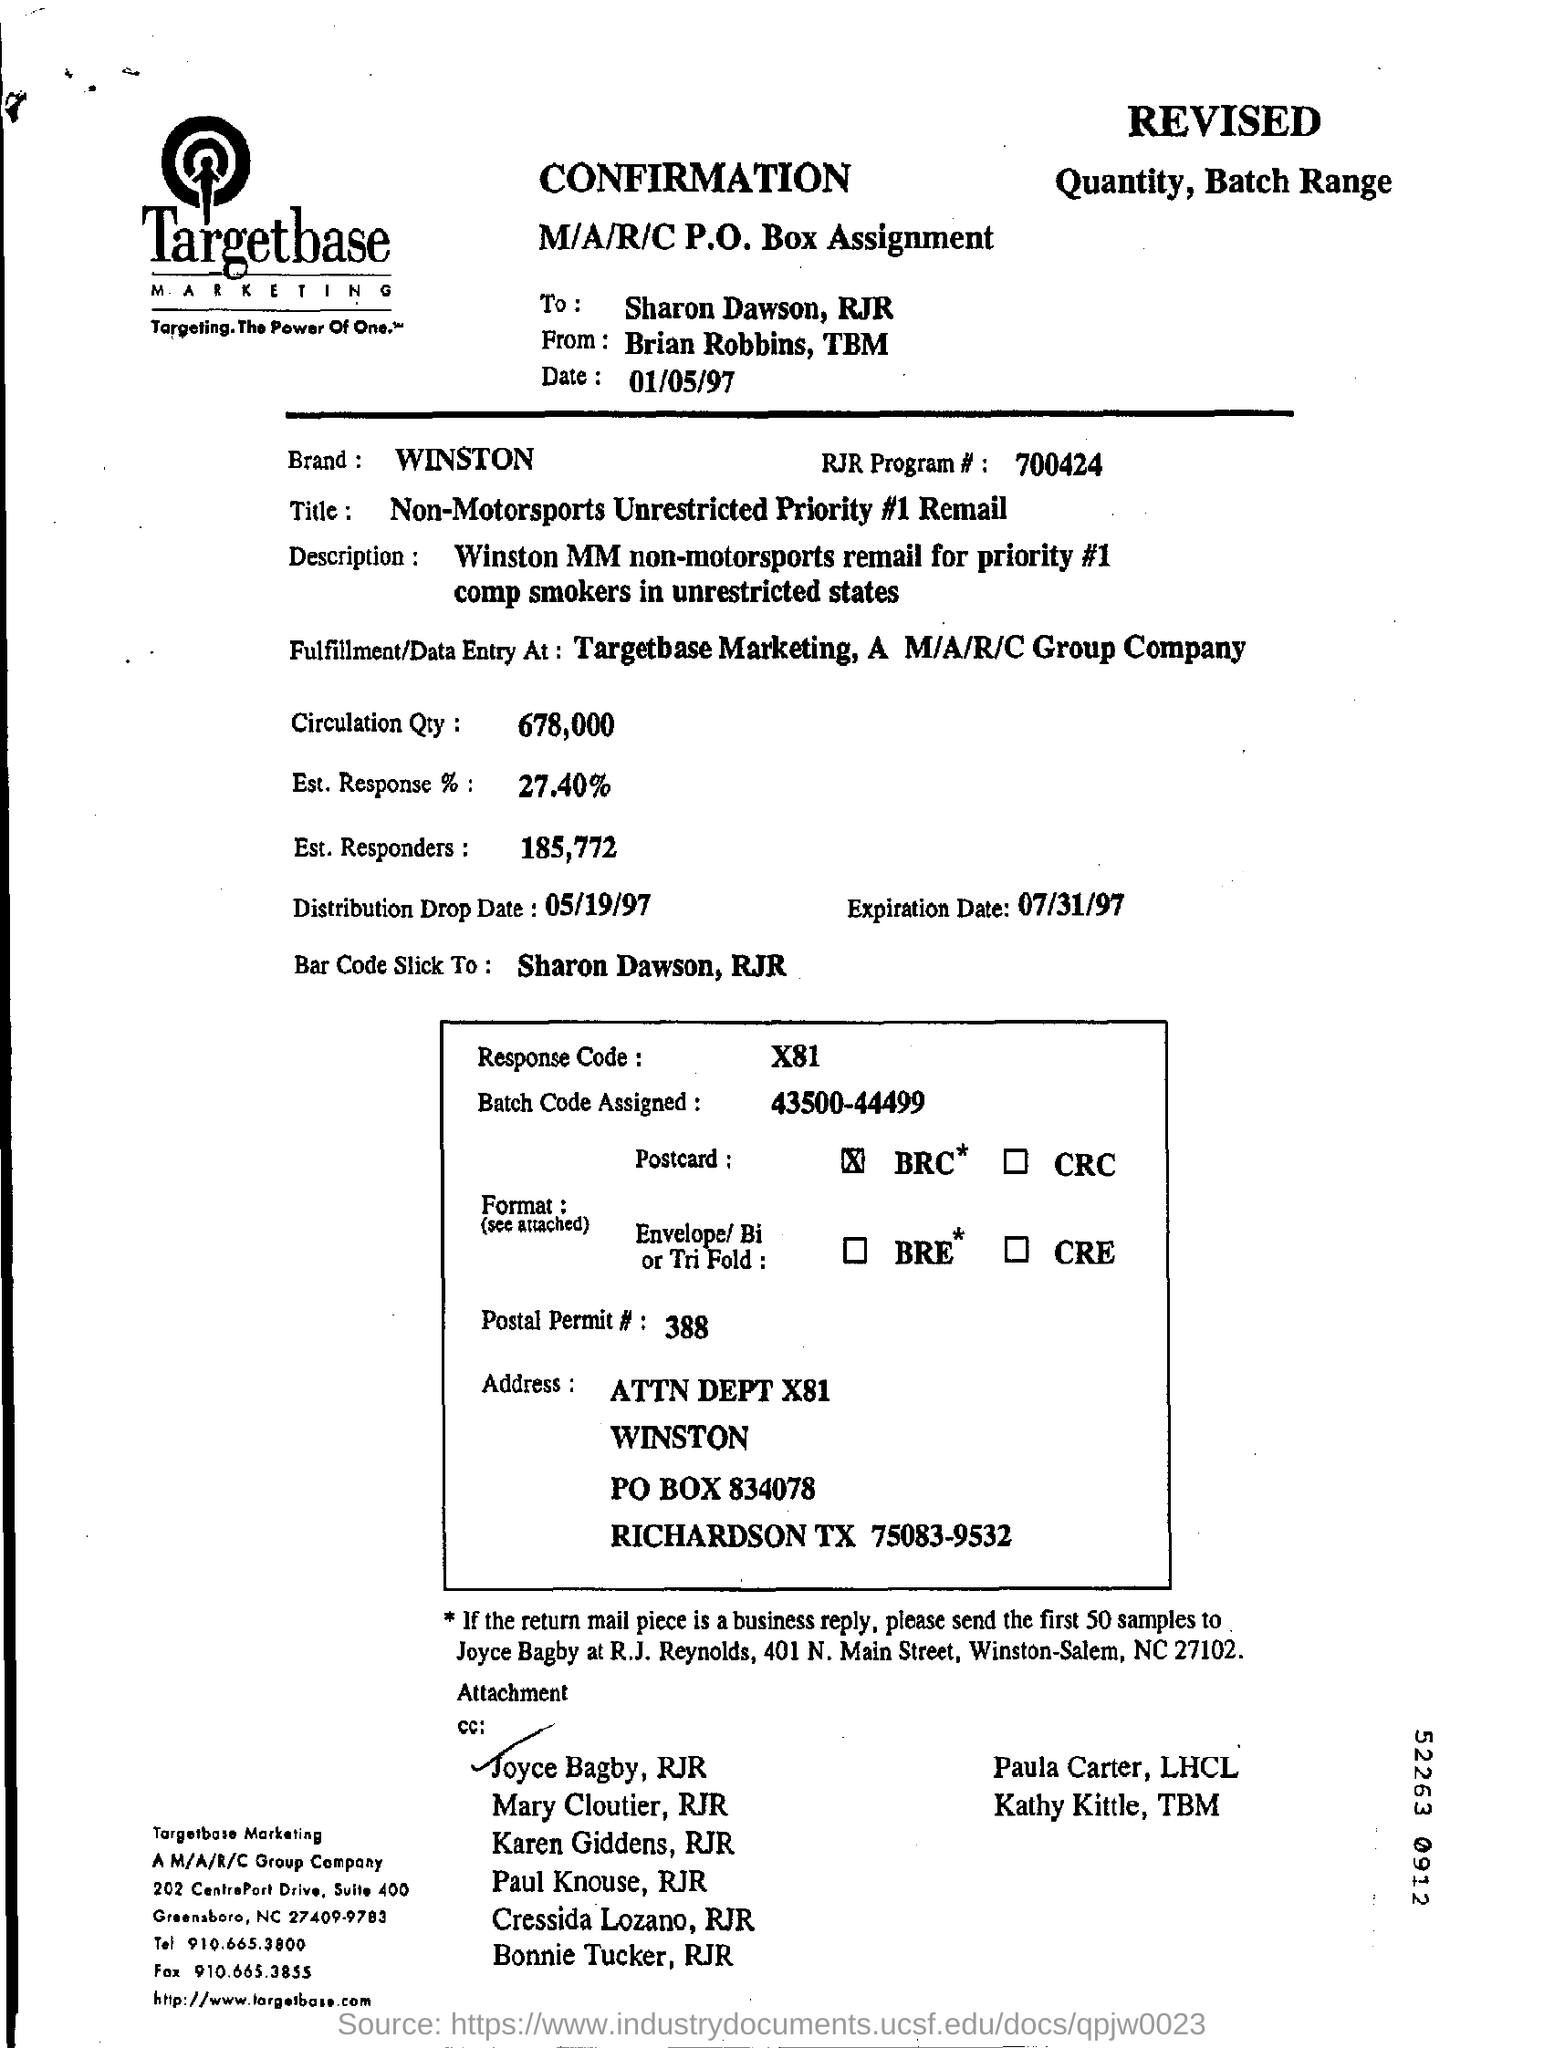List a handful of essential elements in this visual. The batch code assigned is between 43500 and 44499. The date written in this letter is January 5, 1997. WINSTON" is the brand mentioned in the given document. The distribution drop date is May 19, 1997. 